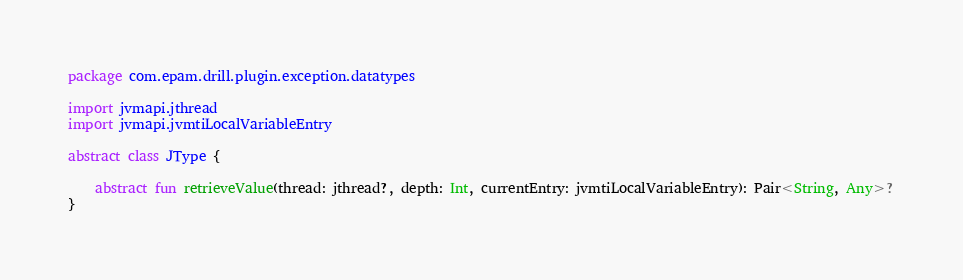Convert code to text. <code><loc_0><loc_0><loc_500><loc_500><_Kotlin_>package com.epam.drill.plugin.exception.datatypes

import jvmapi.jthread
import jvmapi.jvmtiLocalVariableEntry

abstract class JType {

    abstract fun retrieveValue(thread: jthread?, depth: Int, currentEntry: jvmtiLocalVariableEntry): Pair<String, Any>?
}</code> 